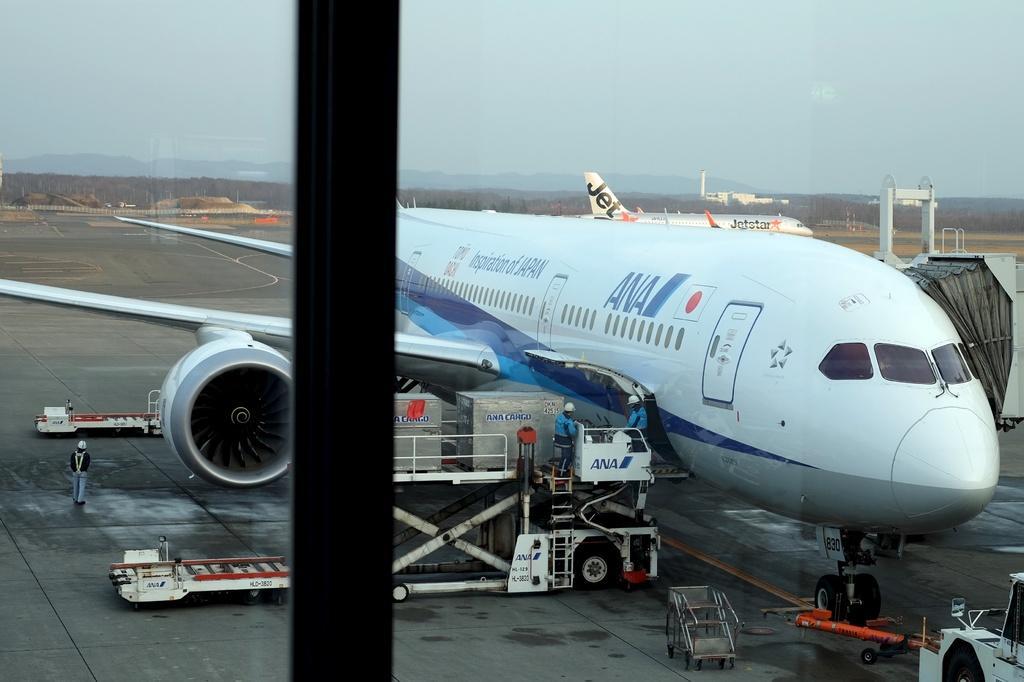How would you summarize this image in a sentence or two? In this picture we can see the mirror, we can see the reflection of planes, few people are standing around. 